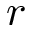Convert formula to latex. <formula><loc_0><loc_0><loc_500><loc_500>r</formula> 